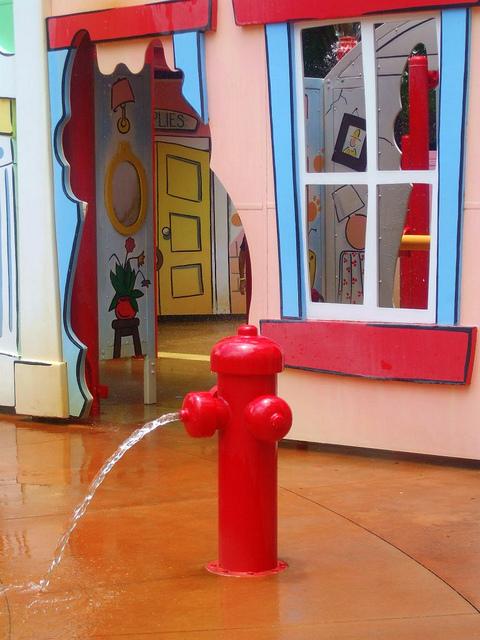What type of house is this?
Concise answer only. Playhouse. What is spraying water?
Keep it brief. Fire hydrant. Is this a real street?
Short answer required. No. 